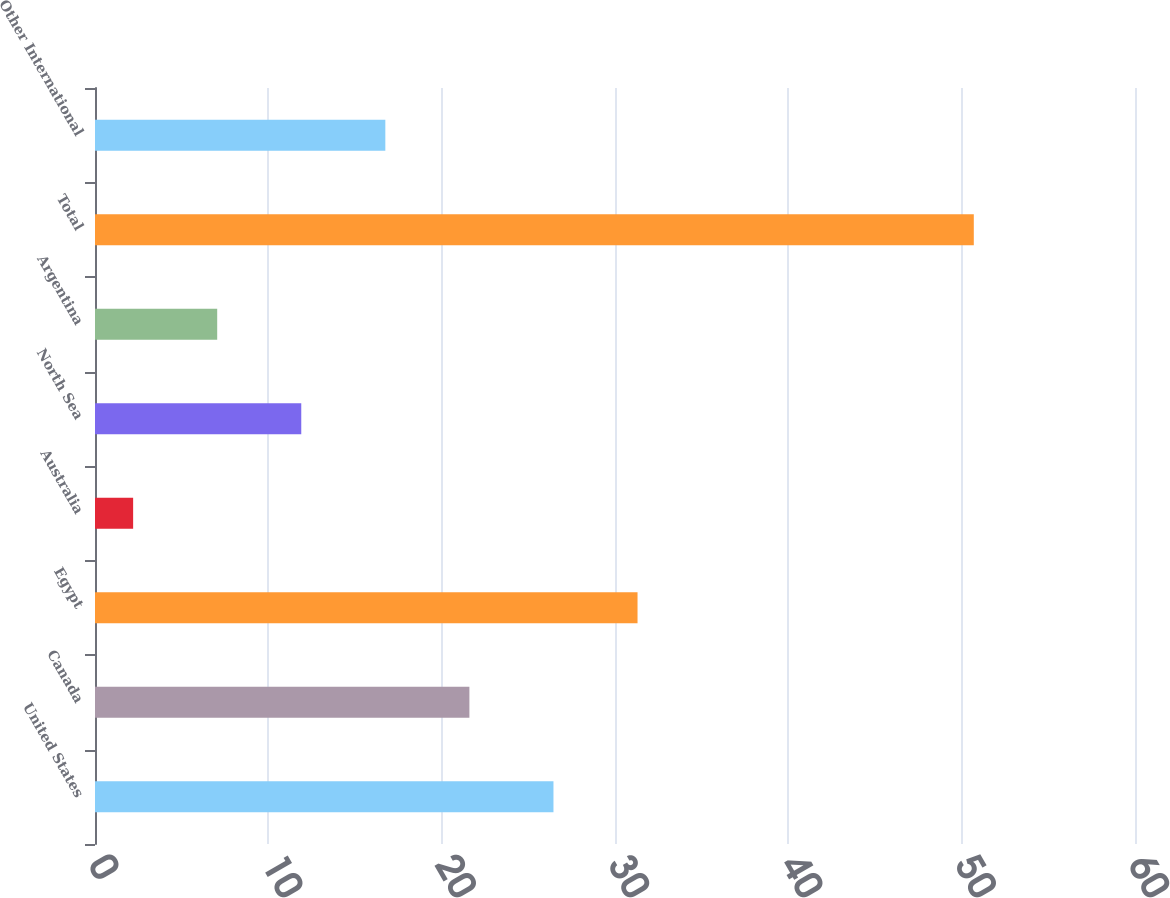<chart> <loc_0><loc_0><loc_500><loc_500><bar_chart><fcel>United States<fcel>Canada<fcel>Egypt<fcel>Australia<fcel>North Sea<fcel>Argentina<fcel>Total<fcel>Other International<nl><fcel>26.45<fcel>21.6<fcel>31.3<fcel>2.2<fcel>11.9<fcel>7.05<fcel>50.7<fcel>16.75<nl></chart> 